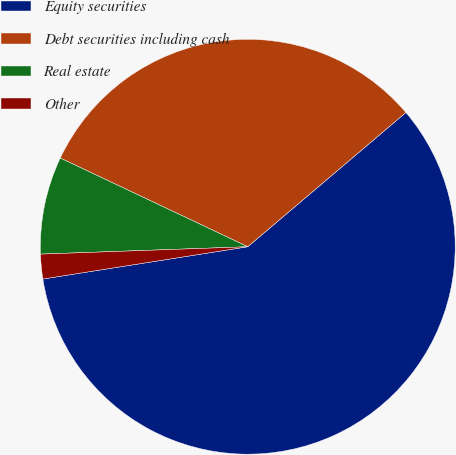<chart> <loc_0><loc_0><loc_500><loc_500><pie_chart><fcel>Equity securities<fcel>Debt securities including cash<fcel>Real estate<fcel>Other<nl><fcel>58.71%<fcel>31.76%<fcel>7.6%<fcel>1.92%<nl></chart> 